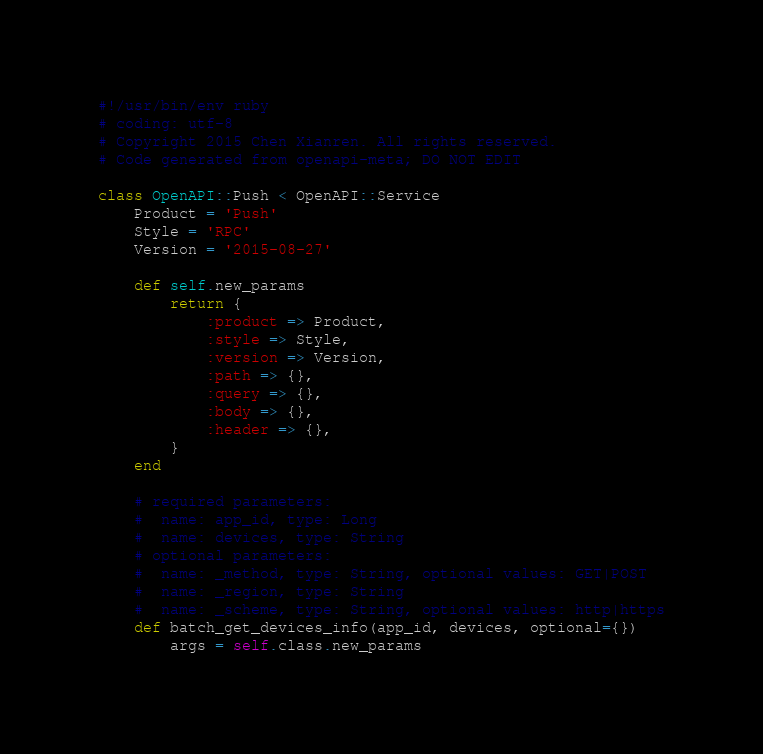Convert code to text. <code><loc_0><loc_0><loc_500><loc_500><_Ruby_>#!/usr/bin/env ruby
# coding: utf-8
# Copyright 2015 Chen Xianren. All rights reserved.
# Code generated from openapi-meta; DO NOT EDIT

class OpenAPI::Push < OpenAPI::Service
	Product = 'Push'
	Style = 'RPC'
	Version = '2015-08-27'

	def self.new_params
		return {
			:product => Product,
			:style => Style,
			:version => Version,
			:path => {},
			:query => {},
			:body => {},
			:header => {},
		}
	end

	# required parameters:
	#  name: app_id, type: Long
	#  name: devices, type: String
	# optional parameters:
	#  name: _method, type: String, optional values: GET|POST
	#  name: _region, type: String
	#  name: _scheme, type: String, optional values: http|https
	def batch_get_devices_info(app_id, devices, optional={})
		args = self.class.new_params</code> 